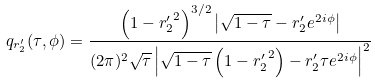<formula> <loc_0><loc_0><loc_500><loc_500>q _ { r ^ { \prime } _ { 2 } } ( \tau , \phi ) = \frac { \left ( 1 - { r ^ { \prime } _ { 2 } } ^ { 2 } \right ) ^ { 3 / 2 } \left | \sqrt { 1 - \tau } - r ^ { \prime } _ { 2 } e ^ { 2 i \phi } \right | } { ( 2 \pi ) ^ { 2 } \sqrt { \tau } \left | \sqrt { 1 - \tau } \left ( 1 - { r ^ { \prime } _ { 2 } } ^ { 2 } \right ) - r ^ { \prime } _ { 2 } \tau e ^ { 2 i \phi } \right | ^ { 2 } }</formula> 